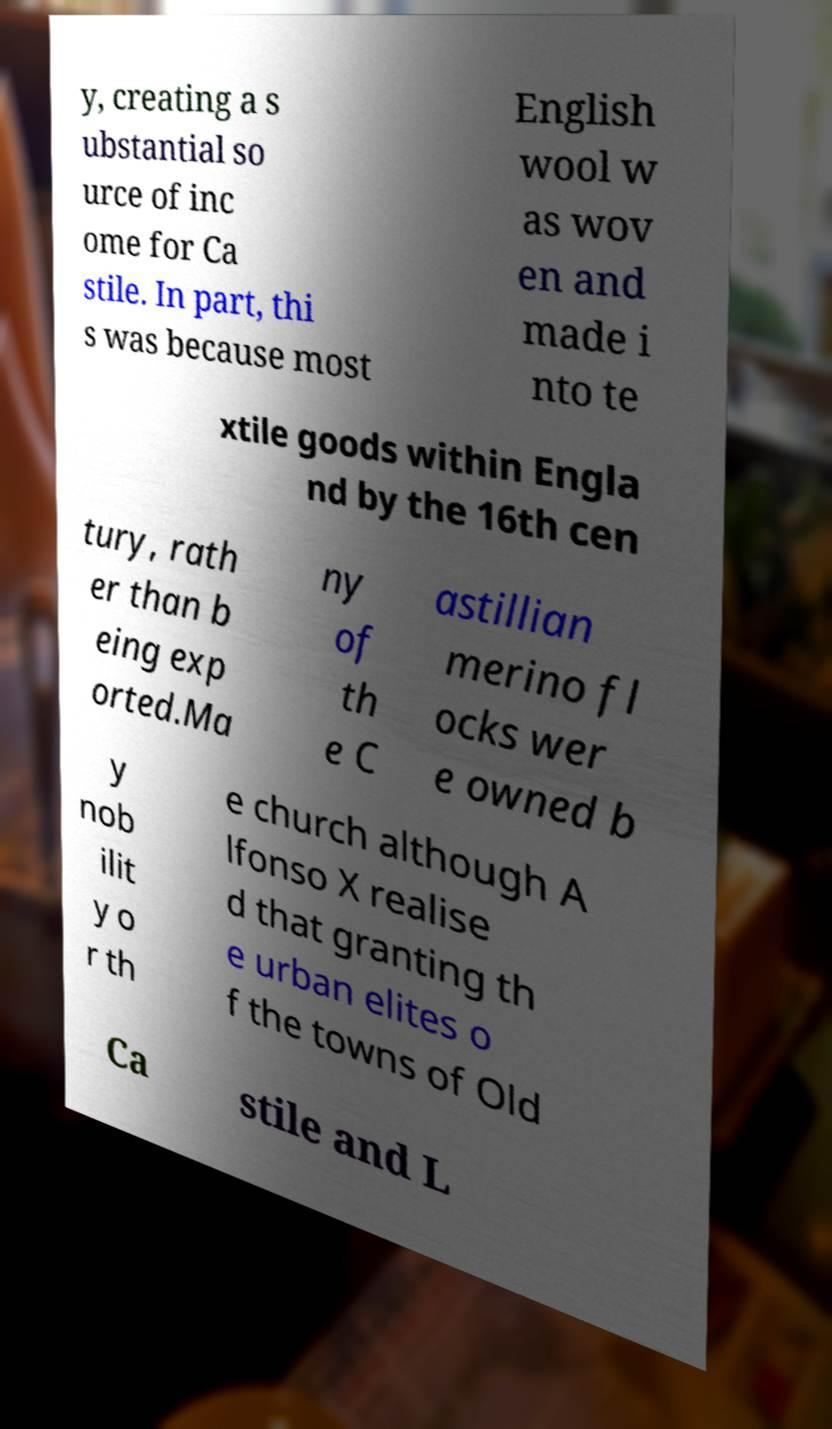What messages or text are displayed in this image? I need them in a readable, typed format. y, creating a s ubstantial so urce of inc ome for Ca stile. In part, thi s was because most English wool w as wov en and made i nto te xtile goods within Engla nd by the 16th cen tury, rath er than b eing exp orted.Ma ny of th e C astillian merino fl ocks wer e owned b y nob ilit y o r th e church although A lfonso X realise d that granting th e urban elites o f the towns of Old Ca stile and L 